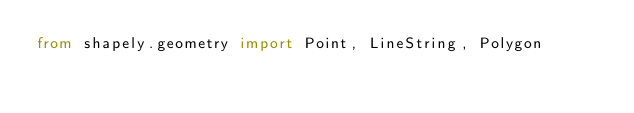Convert code to text. <code><loc_0><loc_0><loc_500><loc_500><_Python_>from shapely.geometry import Point, LineString, Polygon
</code> 